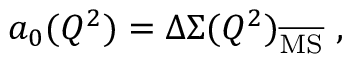Convert formula to latex. <formula><loc_0><loc_0><loc_500><loc_500>a _ { 0 } ( Q ^ { 2 } ) = \Delta \Sigma ( Q ^ { 2 } ) _ { \overline { M S } } ,</formula> 